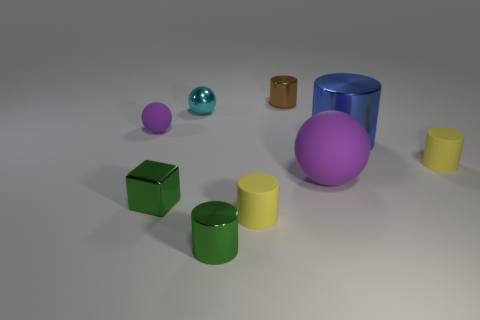There is a green cylinder; are there any green cylinders right of it?
Your response must be concise. No. What material is the thing that is the same color as the metallic cube?
Offer a very short reply. Metal. What number of cylinders are brown objects or small yellow things?
Your response must be concise. 3. Is the shape of the tiny cyan thing the same as the brown object?
Provide a succinct answer. No. There is a purple ball right of the small brown cylinder; what size is it?
Make the answer very short. Large. Are there any tiny metal objects of the same color as the big metallic object?
Provide a succinct answer. No. There is a ball in front of the blue thing; is its size the same as the small cyan thing?
Provide a short and direct response. No. What is the color of the metallic sphere?
Offer a terse response. Cyan. What is the color of the tiny shiny cylinder that is in front of the purple matte sphere left of the small brown cylinder?
Provide a succinct answer. Green. Is there a green object that has the same material as the cyan object?
Offer a very short reply. Yes. 